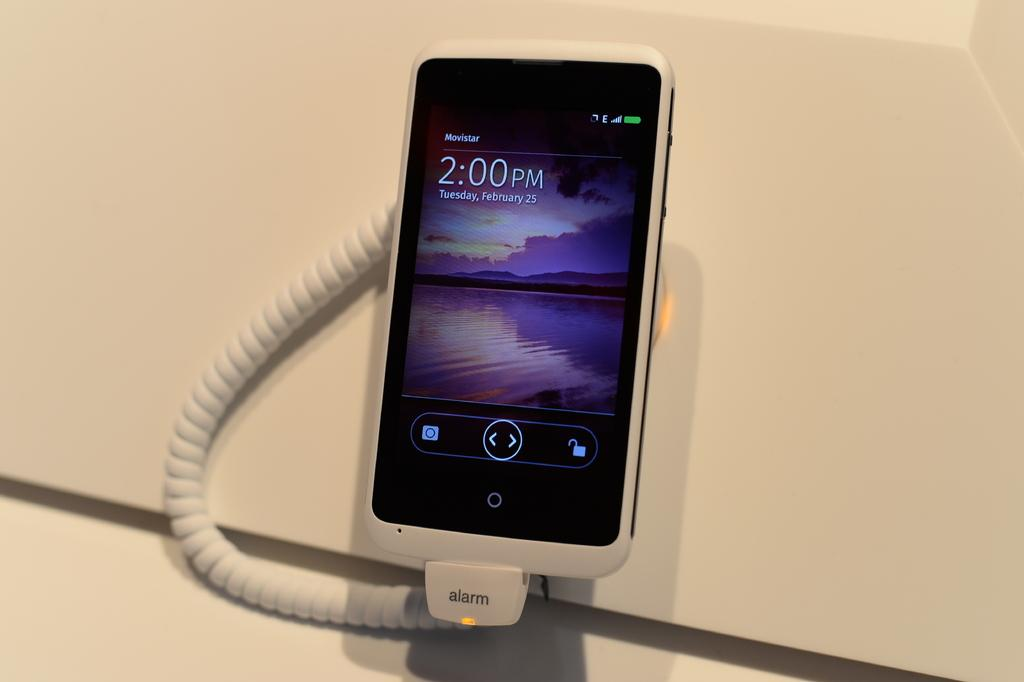<image>
Present a compact description of the photo's key features. a phone that has the time of 2:00 PM on it 